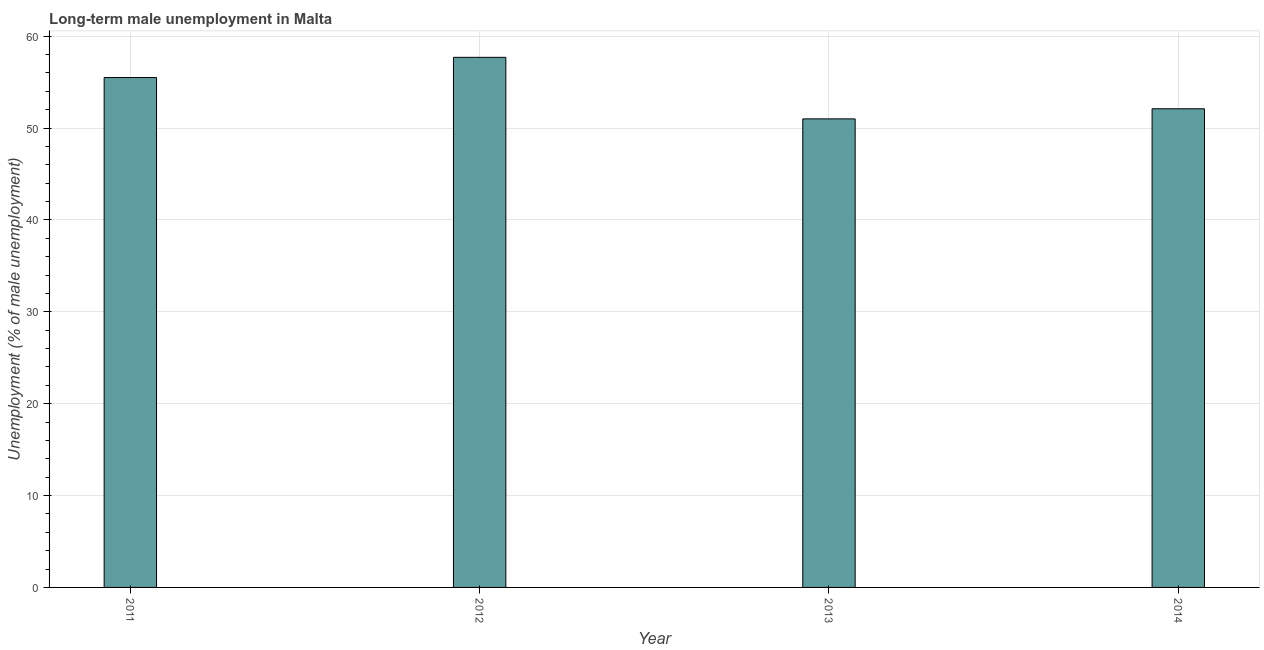Does the graph contain grids?
Make the answer very short. Yes. What is the title of the graph?
Ensure brevity in your answer.  Long-term male unemployment in Malta. What is the label or title of the Y-axis?
Your response must be concise. Unemployment (% of male unemployment). What is the long-term male unemployment in 2012?
Offer a terse response. 57.7. Across all years, what is the maximum long-term male unemployment?
Your response must be concise. 57.7. Across all years, what is the minimum long-term male unemployment?
Your answer should be very brief. 51. In which year was the long-term male unemployment maximum?
Provide a short and direct response. 2012. What is the sum of the long-term male unemployment?
Your answer should be very brief. 216.3. What is the average long-term male unemployment per year?
Keep it short and to the point. 54.08. What is the median long-term male unemployment?
Give a very brief answer. 53.8. What is the ratio of the long-term male unemployment in 2012 to that in 2013?
Your answer should be very brief. 1.13. What is the difference between the highest and the lowest long-term male unemployment?
Give a very brief answer. 6.7. In how many years, is the long-term male unemployment greater than the average long-term male unemployment taken over all years?
Your answer should be compact. 2. How many bars are there?
Your answer should be compact. 4. Are all the bars in the graph horizontal?
Provide a succinct answer. No. How many years are there in the graph?
Give a very brief answer. 4. What is the Unemployment (% of male unemployment) in 2011?
Keep it short and to the point. 55.5. What is the Unemployment (% of male unemployment) of 2012?
Your answer should be compact. 57.7. What is the Unemployment (% of male unemployment) in 2013?
Your answer should be compact. 51. What is the Unemployment (% of male unemployment) in 2014?
Offer a terse response. 52.1. What is the difference between the Unemployment (% of male unemployment) in 2012 and 2013?
Keep it short and to the point. 6.7. What is the ratio of the Unemployment (% of male unemployment) in 2011 to that in 2012?
Make the answer very short. 0.96. What is the ratio of the Unemployment (% of male unemployment) in 2011 to that in 2013?
Your response must be concise. 1.09. What is the ratio of the Unemployment (% of male unemployment) in 2011 to that in 2014?
Provide a short and direct response. 1.06. What is the ratio of the Unemployment (% of male unemployment) in 2012 to that in 2013?
Keep it short and to the point. 1.13. What is the ratio of the Unemployment (% of male unemployment) in 2012 to that in 2014?
Provide a short and direct response. 1.11. 